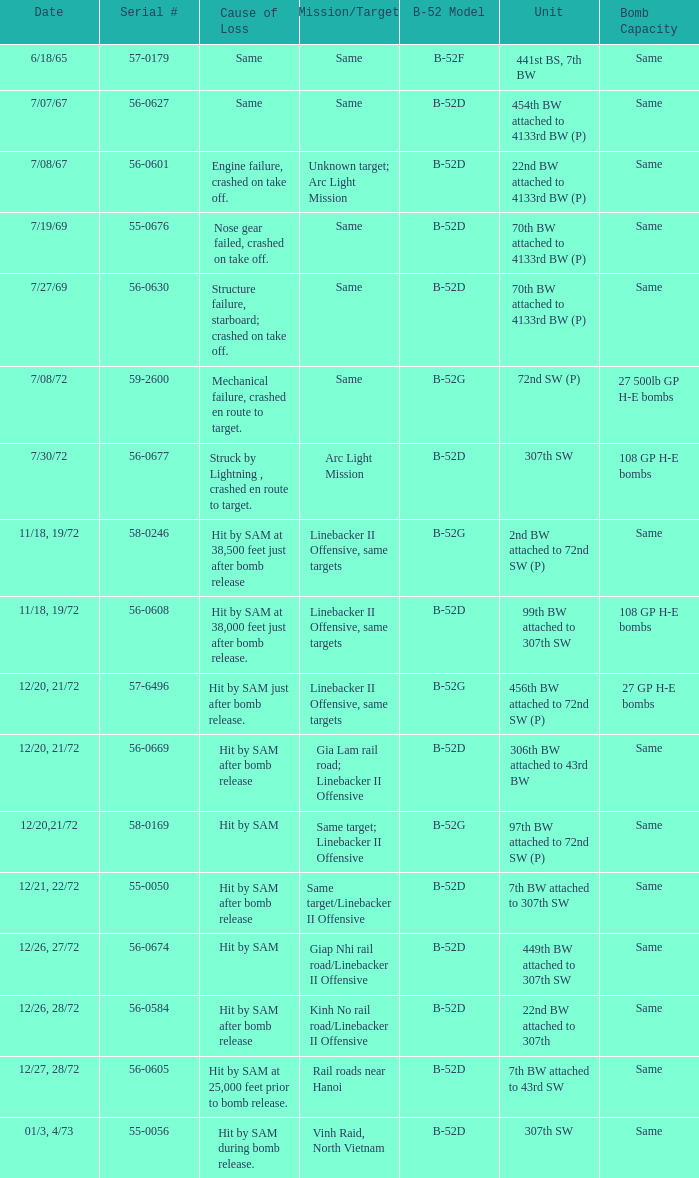When hit by sam at 38,500 feet just after bomb release was the cause of loss what is the mission/target? Linebacker II Offensive, same targets. 